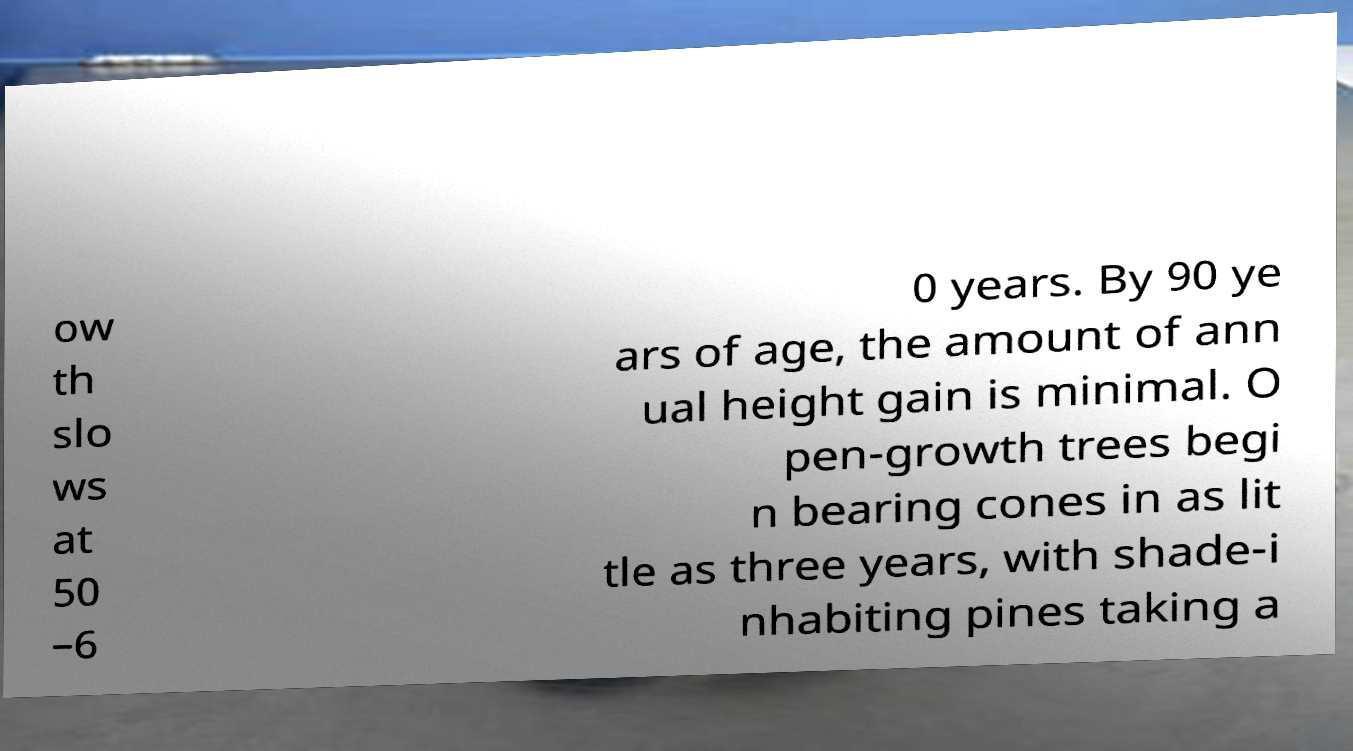Could you extract and type out the text from this image? ow th slo ws at 50 –6 0 years. By 90 ye ars of age, the amount of ann ual height gain is minimal. O pen-growth trees begi n bearing cones in as lit tle as three years, with shade-i nhabiting pines taking a 